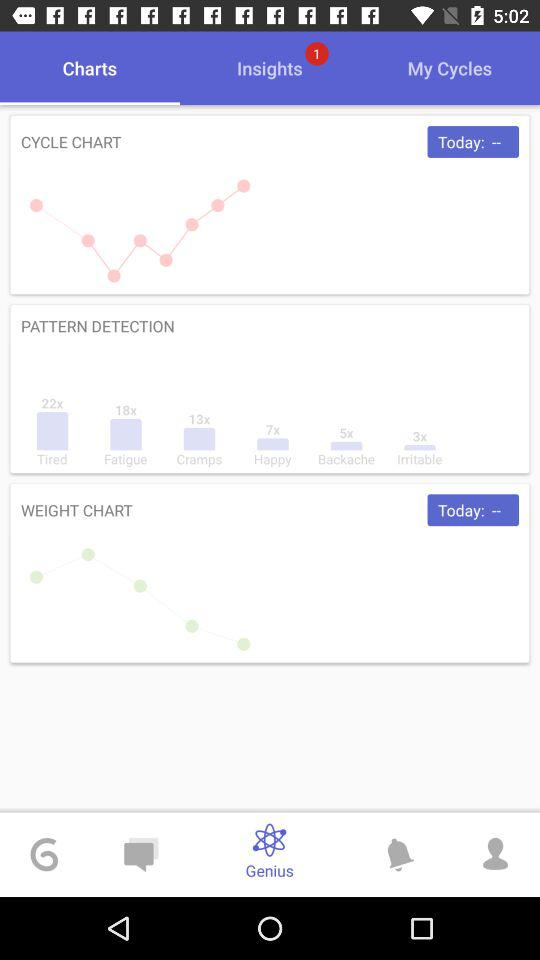How many symptoms have been detected?
Answer the question using a single word or phrase. 6 